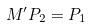<formula> <loc_0><loc_0><loc_500><loc_500>M ^ { \prime } P _ { 2 } = P _ { 1 }</formula> 